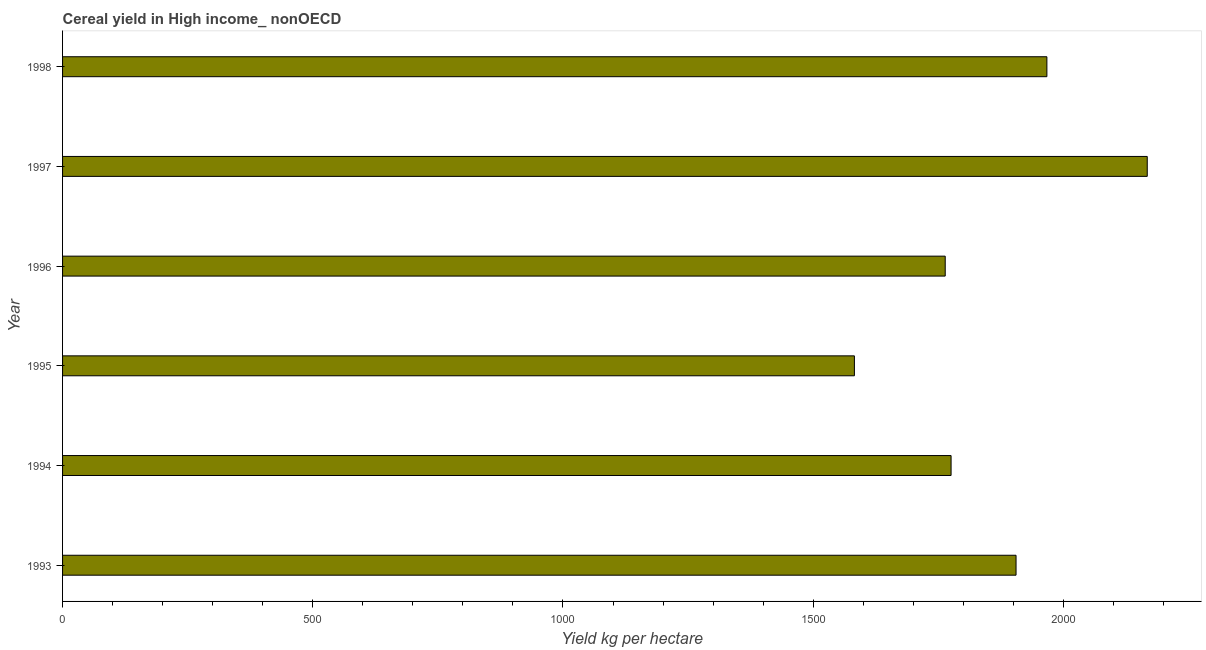Does the graph contain any zero values?
Your answer should be very brief. No. Does the graph contain grids?
Your answer should be very brief. No. What is the title of the graph?
Make the answer very short. Cereal yield in High income_ nonOECD. What is the label or title of the X-axis?
Provide a short and direct response. Yield kg per hectare. What is the label or title of the Y-axis?
Give a very brief answer. Year. What is the cereal yield in 1995?
Provide a succinct answer. 1582.39. Across all years, what is the maximum cereal yield?
Offer a terse response. 2167.6. Across all years, what is the minimum cereal yield?
Keep it short and to the point. 1582.39. In which year was the cereal yield maximum?
Keep it short and to the point. 1997. What is the sum of the cereal yield?
Offer a very short reply. 1.12e+04. What is the difference between the cereal yield in 1994 and 1997?
Offer a very short reply. -392.02. What is the average cereal yield per year?
Your response must be concise. 1860.31. What is the median cereal yield?
Your answer should be very brief. 1840.49. In how many years, is the cereal yield greater than 1200 kg per hectare?
Make the answer very short. 6. Do a majority of the years between 1998 and 1996 (inclusive) have cereal yield greater than 400 kg per hectare?
Your answer should be very brief. Yes. Is the cereal yield in 1996 less than that in 1998?
Give a very brief answer. Yes. What is the difference between the highest and the second highest cereal yield?
Provide a short and direct response. 200.55. Is the sum of the cereal yield in 1997 and 1998 greater than the maximum cereal yield across all years?
Your answer should be compact. Yes. What is the difference between the highest and the lowest cereal yield?
Your answer should be very brief. 585.21. In how many years, is the cereal yield greater than the average cereal yield taken over all years?
Offer a terse response. 3. How many years are there in the graph?
Provide a short and direct response. 6. What is the difference between two consecutive major ticks on the X-axis?
Keep it short and to the point. 500. What is the Yield kg per hectare in 1993?
Your answer should be very brief. 1905.4. What is the Yield kg per hectare of 1994?
Make the answer very short. 1775.57. What is the Yield kg per hectare in 1995?
Offer a terse response. 1582.39. What is the Yield kg per hectare in 1996?
Your answer should be very brief. 1763.84. What is the Yield kg per hectare in 1997?
Offer a terse response. 2167.6. What is the Yield kg per hectare of 1998?
Provide a succinct answer. 1967.04. What is the difference between the Yield kg per hectare in 1993 and 1994?
Offer a terse response. 129.82. What is the difference between the Yield kg per hectare in 1993 and 1995?
Your answer should be very brief. 323.01. What is the difference between the Yield kg per hectare in 1993 and 1996?
Offer a terse response. 141.56. What is the difference between the Yield kg per hectare in 1993 and 1997?
Make the answer very short. -262.2. What is the difference between the Yield kg per hectare in 1993 and 1998?
Your response must be concise. -61.65. What is the difference between the Yield kg per hectare in 1994 and 1995?
Keep it short and to the point. 193.19. What is the difference between the Yield kg per hectare in 1994 and 1996?
Provide a succinct answer. 11.73. What is the difference between the Yield kg per hectare in 1994 and 1997?
Your answer should be very brief. -392.02. What is the difference between the Yield kg per hectare in 1994 and 1998?
Give a very brief answer. -191.47. What is the difference between the Yield kg per hectare in 1995 and 1996?
Keep it short and to the point. -181.45. What is the difference between the Yield kg per hectare in 1995 and 1997?
Provide a short and direct response. -585.21. What is the difference between the Yield kg per hectare in 1995 and 1998?
Provide a succinct answer. -384.65. What is the difference between the Yield kg per hectare in 1996 and 1997?
Your answer should be compact. -403.75. What is the difference between the Yield kg per hectare in 1996 and 1998?
Ensure brevity in your answer.  -203.2. What is the difference between the Yield kg per hectare in 1997 and 1998?
Give a very brief answer. 200.55. What is the ratio of the Yield kg per hectare in 1993 to that in 1994?
Provide a short and direct response. 1.07. What is the ratio of the Yield kg per hectare in 1993 to that in 1995?
Offer a terse response. 1.2. What is the ratio of the Yield kg per hectare in 1993 to that in 1996?
Your answer should be very brief. 1.08. What is the ratio of the Yield kg per hectare in 1993 to that in 1997?
Your answer should be very brief. 0.88. What is the ratio of the Yield kg per hectare in 1994 to that in 1995?
Offer a terse response. 1.12. What is the ratio of the Yield kg per hectare in 1994 to that in 1996?
Your response must be concise. 1.01. What is the ratio of the Yield kg per hectare in 1994 to that in 1997?
Offer a very short reply. 0.82. What is the ratio of the Yield kg per hectare in 1994 to that in 1998?
Provide a succinct answer. 0.9. What is the ratio of the Yield kg per hectare in 1995 to that in 1996?
Keep it short and to the point. 0.9. What is the ratio of the Yield kg per hectare in 1995 to that in 1997?
Offer a very short reply. 0.73. What is the ratio of the Yield kg per hectare in 1995 to that in 1998?
Your answer should be compact. 0.8. What is the ratio of the Yield kg per hectare in 1996 to that in 1997?
Your answer should be very brief. 0.81. What is the ratio of the Yield kg per hectare in 1996 to that in 1998?
Your response must be concise. 0.9. What is the ratio of the Yield kg per hectare in 1997 to that in 1998?
Make the answer very short. 1.1. 